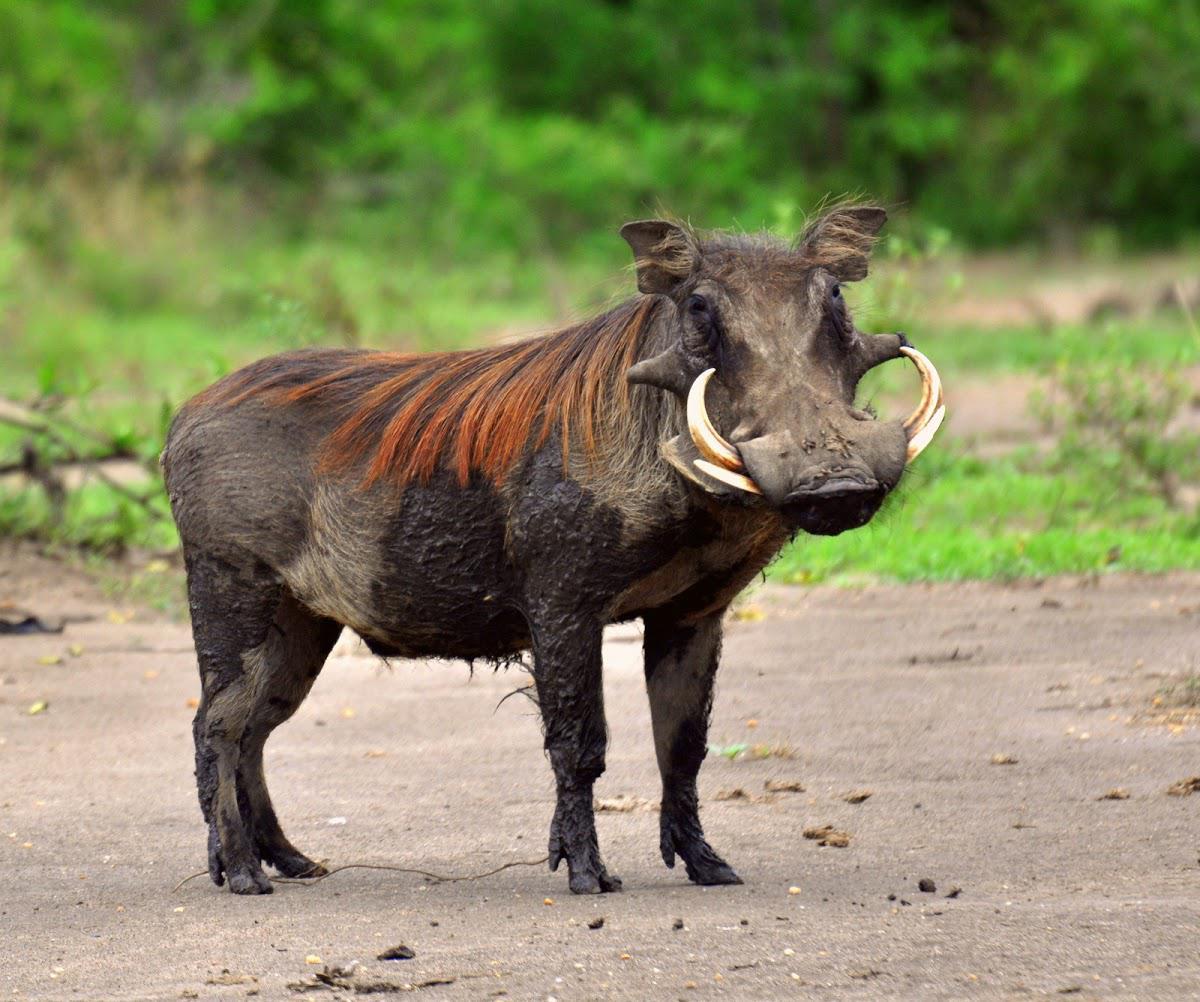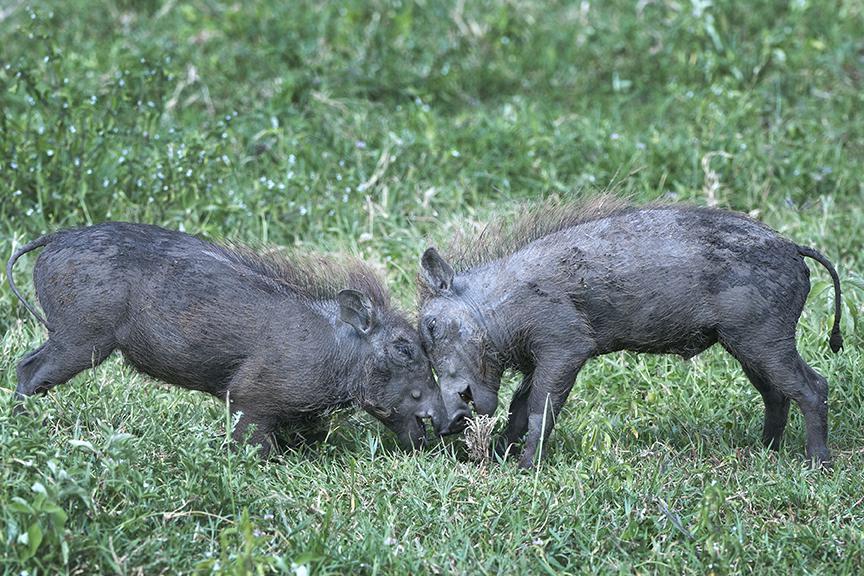The first image is the image on the left, the second image is the image on the right. Considering the images on both sides, is "There are at least 4 hogs standing in grass." valid? Answer yes or no. No. The first image is the image on the left, the second image is the image on the right. Considering the images on both sides, is "Left image shows one warthog with body in profile turned to the right." valid? Answer yes or no. Yes. 